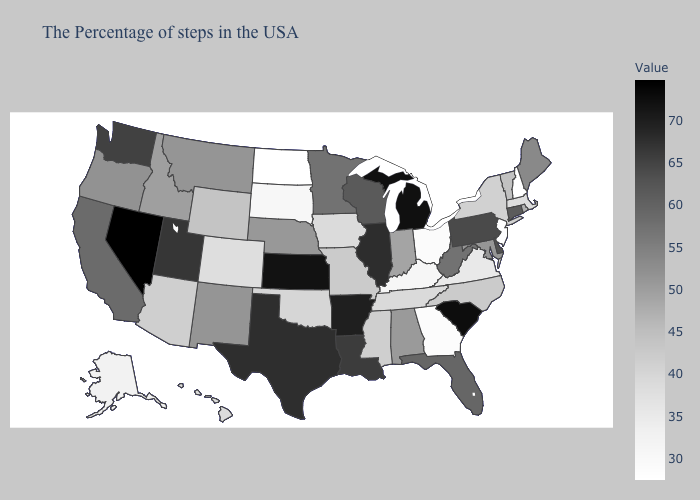Does Michigan have the lowest value in the USA?
Be succinct. No. Does Rhode Island have the lowest value in the Northeast?
Give a very brief answer. No. Among the states that border Oklahoma , does Missouri have the lowest value?
Give a very brief answer. No. Does South Dakota have the lowest value in the USA?
Keep it brief. No. Among the states that border New York , which have the highest value?
Keep it brief. Pennsylvania. Which states have the lowest value in the West?
Short answer required. Alaska. 